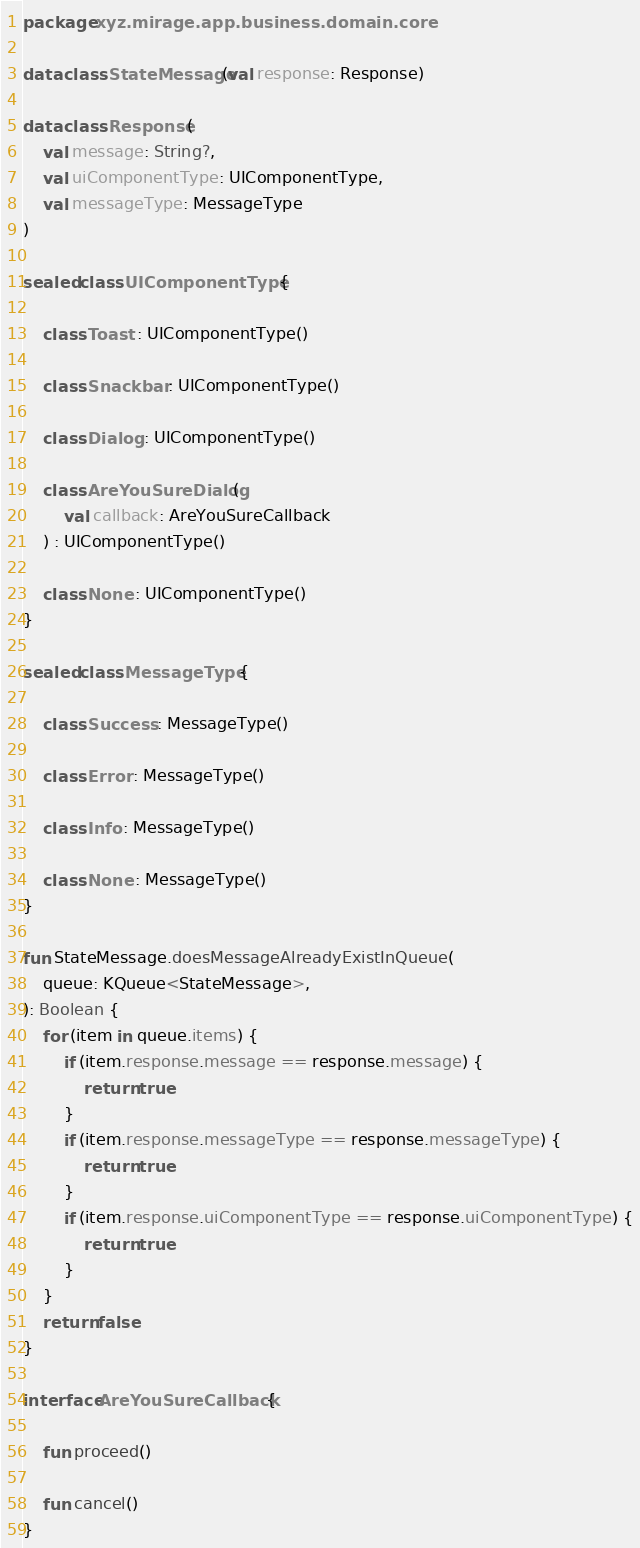<code> <loc_0><loc_0><loc_500><loc_500><_Kotlin_>package xyz.mirage.app.business.domain.core

data class StateMessage(val response: Response)

data class Response(
    val message: String?,
    val uiComponentType: UIComponentType,
    val messageType: MessageType
)

sealed class UIComponentType {

    class Toast : UIComponentType()

    class Snackbar : UIComponentType()

    class Dialog : UIComponentType()

    class AreYouSureDialog(
        val callback: AreYouSureCallback
    ) : UIComponentType()

    class None : UIComponentType()
}

sealed class MessageType {

    class Success : MessageType()

    class Error : MessageType()

    class Info : MessageType()

    class None : MessageType()
}

fun StateMessage.doesMessageAlreadyExistInQueue(
    queue: KQueue<StateMessage>,
): Boolean {
    for (item in queue.items) {
        if (item.response.message == response.message) {
            return true
        }
        if (item.response.messageType == response.messageType) {
            return true
        }
        if (item.response.uiComponentType == response.uiComponentType) {
            return true
        }
    }
    return false
}

interface AreYouSureCallback {

    fun proceed()

    fun cancel()
}
</code> 